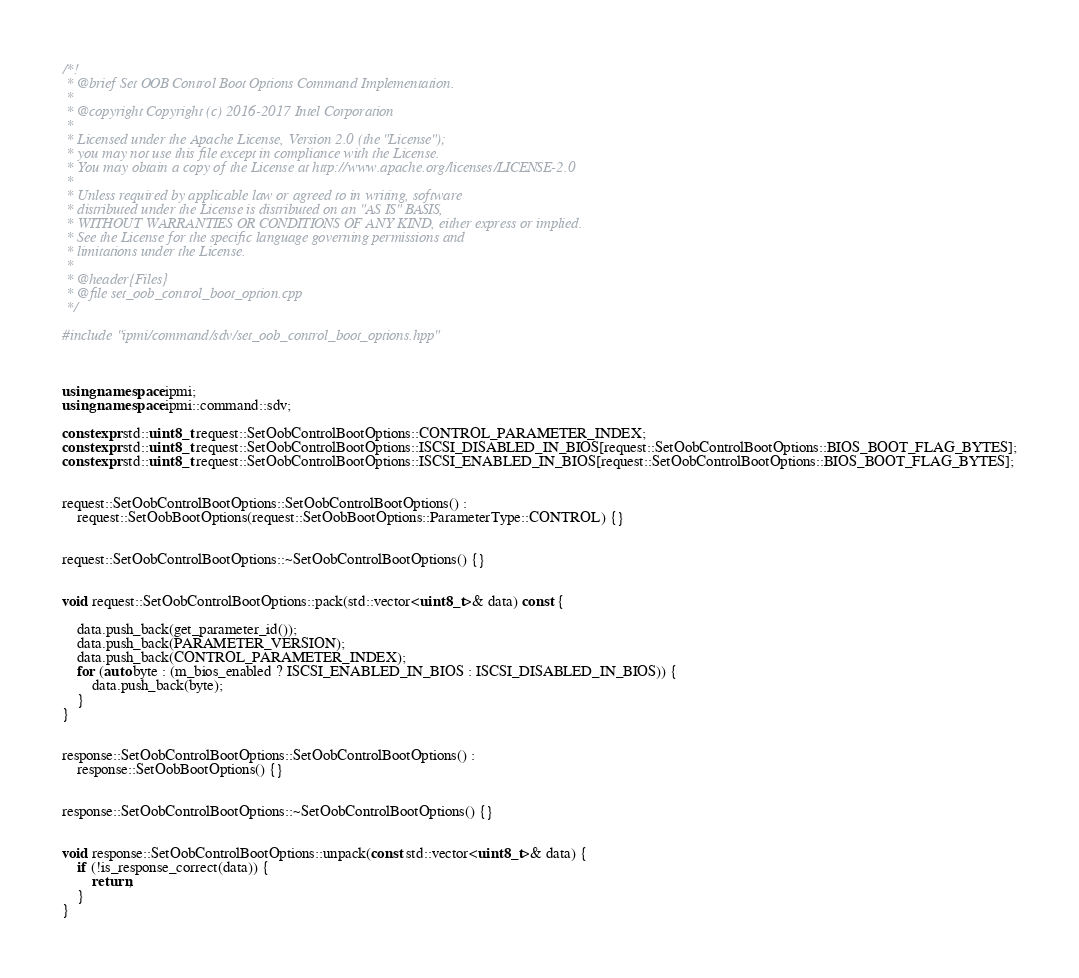Convert code to text. <code><loc_0><loc_0><loc_500><loc_500><_C++_>/*!
 * @brief Set OOB Control Boot Options Command Implementation.
 *
 * @copyright Copyright (c) 2016-2017 Intel Corporation
 *
 * Licensed under the Apache License, Version 2.0 (the "License");
 * you may not use this file except in compliance with the License.
 * You may obtain a copy of the License at http://www.apache.org/licenses/LICENSE-2.0
 *
 * Unless required by applicable law or agreed to in writing, software
 * distributed under the License is distributed on an "AS IS" BASIS,
 * WITHOUT WARRANTIES OR CONDITIONS OF ANY KIND, either express or implied.
 * See the License for the specific language governing permissions and
 * limitations under the License.
 *
 * @header{Files}
 * @file set_oob_control_boot_option.cpp
 */

#include "ipmi/command/sdv/set_oob_control_boot_options.hpp"



using namespace ipmi;
using namespace ipmi::command::sdv;

constexpr std::uint8_t request::SetOobControlBootOptions::CONTROL_PARAMETER_INDEX;
constexpr std::uint8_t request::SetOobControlBootOptions::ISCSI_DISABLED_IN_BIOS[request::SetOobControlBootOptions::BIOS_BOOT_FLAG_BYTES];
constexpr std::uint8_t request::SetOobControlBootOptions::ISCSI_ENABLED_IN_BIOS[request::SetOobControlBootOptions::BIOS_BOOT_FLAG_BYTES];


request::SetOobControlBootOptions::SetOobControlBootOptions() :
    request::SetOobBootOptions(request::SetOobBootOptions::ParameterType::CONTROL) {}


request::SetOobControlBootOptions::~SetOobControlBootOptions() {}


void request::SetOobControlBootOptions::pack(std::vector<uint8_t>& data) const {

    data.push_back(get_parameter_id());
    data.push_back(PARAMETER_VERSION);
    data.push_back(CONTROL_PARAMETER_INDEX);
    for (auto byte : (m_bios_enabled ? ISCSI_ENABLED_IN_BIOS : ISCSI_DISABLED_IN_BIOS)) {
        data.push_back(byte);
    }
}


response::SetOobControlBootOptions::SetOobControlBootOptions() :
    response::SetOobBootOptions() {}


response::SetOobControlBootOptions::~SetOobControlBootOptions() {}


void response::SetOobControlBootOptions::unpack(const std::vector<uint8_t>& data) {
    if (!is_response_correct(data)) {
        return;
    }
}
</code> 